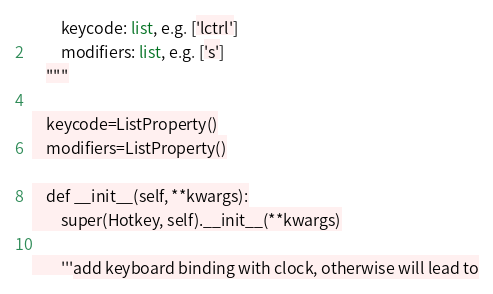<code> <loc_0><loc_0><loc_500><loc_500><_Python_>        keycode: list, e.g. ['lctrl']
        modifiers: list, e.g. ['s']
    """

    keycode=ListProperty()
    modifiers=ListProperty()

    def __init__(self, **kwargs):
        super(Hotkey, self).__init__(**kwargs)

        '''add keyboard binding with clock, otherwise will lead to</code> 